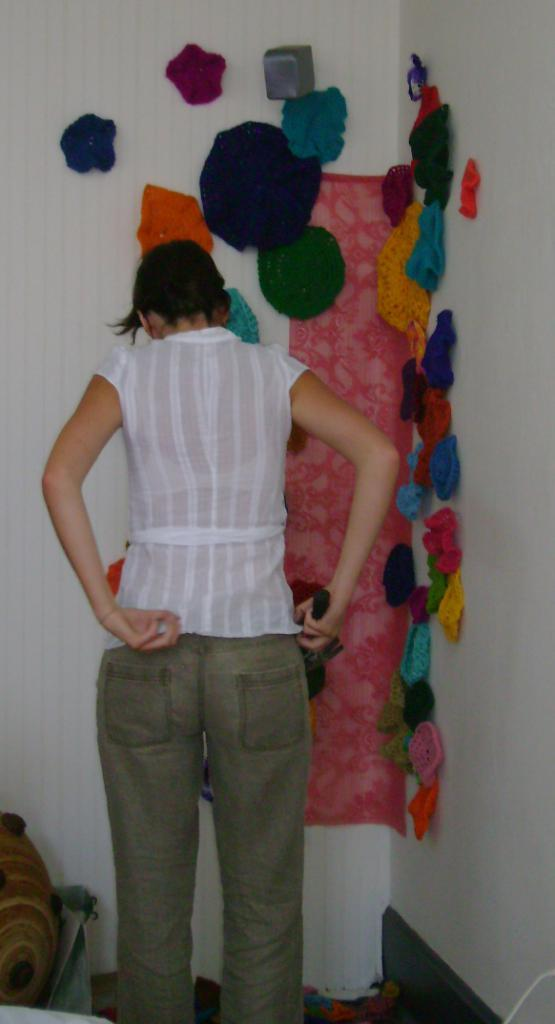What is the primary subject of the image? There is a woman standing in the image. Where is the woman positioned in the image? The woman is standing on the floor. What can be seen hanging on the wall in the image? There are woolen clothes hanging on the wall in the image. What type of stone is the woman using to express her desire in the image? There is no stone or expression of desire present in the image. Is there a volcano visible in the background of the image? No, there is no volcano visible in the image. 